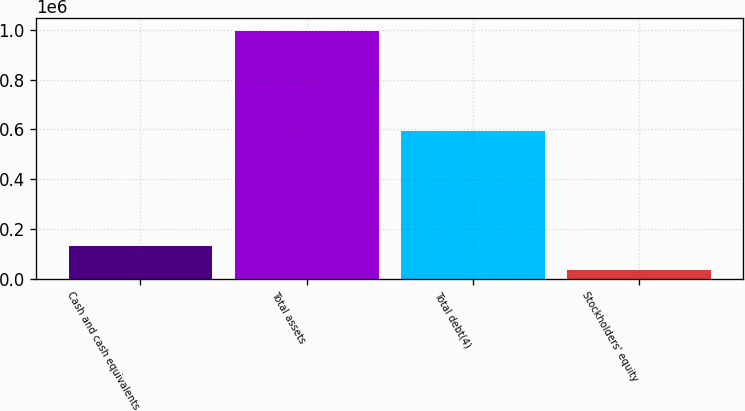Convert chart to OTSL. <chart><loc_0><loc_0><loc_500><loc_500><bar_chart><fcel>Cash and cash equivalents<fcel>Total assets<fcel>Total debt(4)<fcel>Stockholders' equity<nl><fcel>131149<fcel>996953<fcel>594169<fcel>34949<nl></chart> 